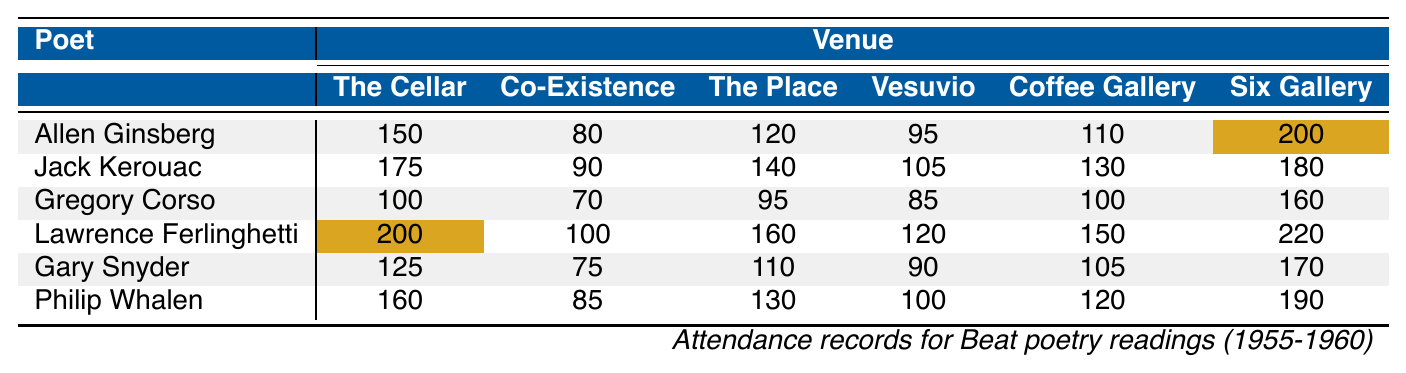What was the highest attendance recorded at "The Six Gallery"? Looking at the column for "The Six Gallery," we note the attendance figures: 200, 180, 160, 220, 170, and 190. The highest value is 220.
Answer: 220 Who had the lowest attendance at "The Co-Existence Bagel Shop"? The attendance numbers for "The Co-Existence Bagel Shop" are 80, 90, 70, 100, 75, and 85. The lowest among these is 70.
Answer: 70 Which poet had the highest total attendance across all venues? We sum the attendance for each poet across all venues: Allen Ginsberg (150 + 80 + 120 + 95 + 110 + 200 = 755), Jack Kerouac (175 + 90 + 140 + 105 + 130 + 180 = 920), Gregory Corso (100 + 70 + 95 + 85 + 100 + 160 = 610), Lawrence Ferlinghetti (200 + 100 + 160 + 120 + 150 + 220 = 1050), Gary Snyder (125 + 75 + 110 + 90 + 105 + 170 = 675), and Philip Whalen (160 + 85 + 130 + 100 + 120 + 190 = 785). The highest total is 1050 for Lawrence Ferlinghetti.
Answer: Lawrence Ferlinghetti What is the median attendance for Jack Kerouac? The attendance numbers for Jack Kerouac are 175, 90, 140, 105, 130, and 180. When ordered (90, 105, 130, 140, 175, 180), the median is the average of the 3rd and 4th values: (130 + 140) / 2 = 135.
Answer: 135 Was the attendance at "The Coffee Gallery" higher for any poet than 150? Checking the values for "The Coffee Gallery": 110, 130, 100, 150, 105, and 120. Only Lawrence Ferlinghetti has an attendance of exactly 150, thus none exceed 150.
Answer: No Calculate the average attendance across all venues for Gregory Corso. Gregory Corso's attendance figures are 100, 70, 95, 85, 100, and 160. The sum is (100 + 70 + 95 + 85 + 100 + 160) = 610, and there are 6 readings. Average attendance = 610 / 6 = 101.67 (rounded to 102).
Answer: 102 Which venue had the highest overall average attendance? Calculate the average attendance for each venue: The Cellar (150+175+100+200+125+160)/6=143.33, Co-Existence (80+90+70+100+75+85)/6=83.33, The Place (120+140+95+160+110+130)/6=124.17, Vesuvio (95+105+85+120+90+100)/6=99.17, Coffee Gallery (110+130+100+150+105+120)/6=120.83, Six Gallery (200+180+160+220+170+190)/6=185.00. The highest average is at The Six Gallery with 185.00.
Answer: The Six Gallery Did any poet have the same attendance in multiple venues? Looking through the attendance numbers for each poet, no poet is listed with the same figure for two or more venues.
Answer: No 